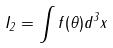<formula> <loc_0><loc_0><loc_500><loc_500>I _ { 2 } = \int f ( \theta ) d ^ { 3 } x</formula> 